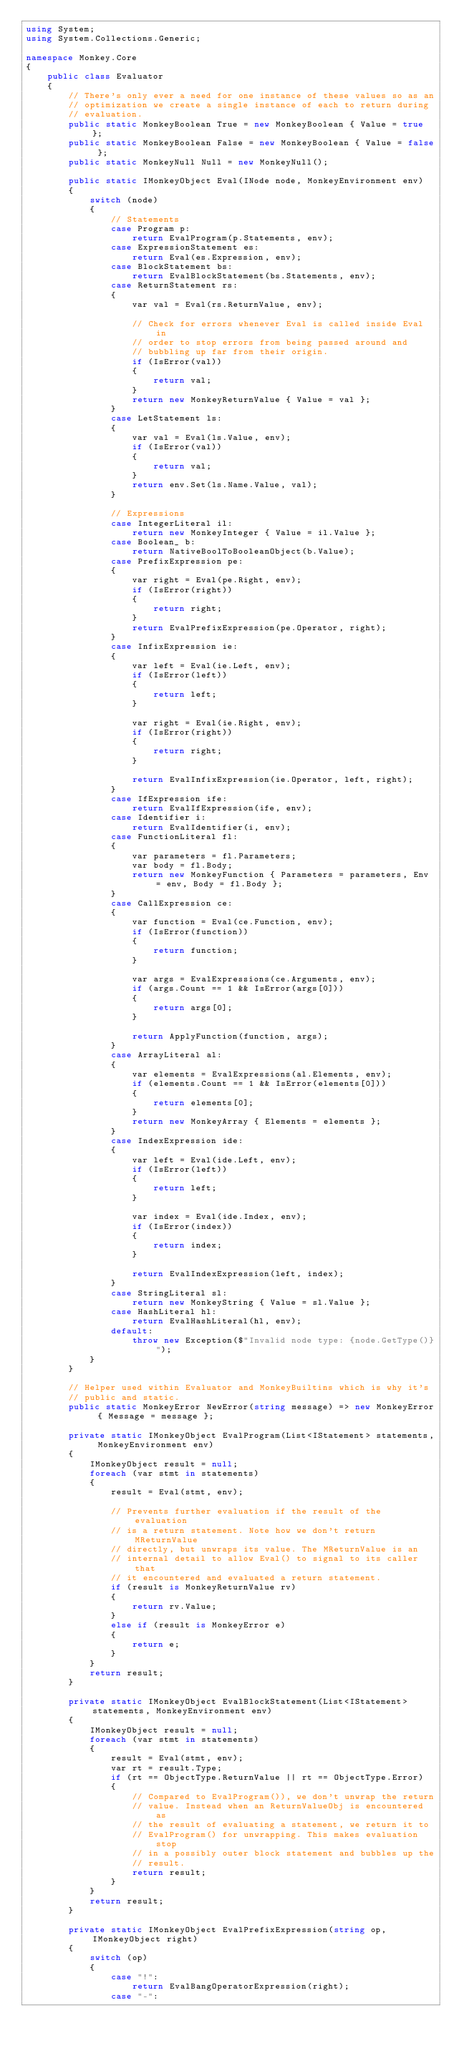Convert code to text. <code><loc_0><loc_0><loc_500><loc_500><_C#_>using System;
using System.Collections.Generic;

namespace Monkey.Core
{
    public class Evaluator
    {
        // There's only ever a need for one instance of these values so as an
        // optimization we create a single instance of each to return during
        // evaluation.
        public static MonkeyBoolean True = new MonkeyBoolean { Value = true };
        public static MonkeyBoolean False = new MonkeyBoolean { Value = false };
        public static MonkeyNull Null = new MonkeyNull();

        public static IMonkeyObject Eval(INode node, MonkeyEnvironment env)
        {
            switch (node)
            {
                // Statements
                case Program p:
                    return EvalProgram(p.Statements, env);
                case ExpressionStatement es:
                    return Eval(es.Expression, env);
                case BlockStatement bs:
                    return EvalBlockStatement(bs.Statements, env);
                case ReturnStatement rs:
                {
                    var val = Eval(rs.ReturnValue, env);

                    // Check for errors whenever Eval is called inside Eval in
                    // order to stop errors from being passed around and
                    // bubbling up far from their origin.
                    if (IsError(val))
                    {
                        return val;
                    }
                    return new MonkeyReturnValue { Value = val };
                }
                case LetStatement ls:
                {
                    var val = Eval(ls.Value, env);
                    if (IsError(val))
                    {
                        return val;
                    }
                    return env.Set(ls.Name.Value, val);
                }

                // Expressions
                case IntegerLiteral il:
                    return new MonkeyInteger { Value = il.Value };
                case Boolean_ b:
                    return NativeBoolToBooleanObject(b.Value);
                case PrefixExpression pe:
                {
                    var right = Eval(pe.Right, env);
                    if (IsError(right))
                    {
                        return right;
                    }
                    return EvalPrefixExpression(pe.Operator, right);
                }
                case InfixExpression ie:
                {
                    var left = Eval(ie.Left, env);
                    if (IsError(left))
                    {
                        return left;
                    }

                    var right = Eval(ie.Right, env);
                    if (IsError(right))
                    {
                        return right;
                    }

                    return EvalInfixExpression(ie.Operator, left, right);
                }
                case IfExpression ife:
                    return EvalIfExpression(ife, env);
                case Identifier i:
                    return EvalIdentifier(i, env);
                case FunctionLiteral fl:
                {
                    var parameters = fl.Parameters;   
                    var body = fl.Body;
                    return new MonkeyFunction { Parameters = parameters, Env = env, Body = fl.Body };
                }
                case CallExpression ce:
                {
                    var function = Eval(ce.Function, env);
                    if (IsError(function))
                    {
                        return function;
                    }
                    
                    var args = EvalExpressions(ce.Arguments, env);
                    if (args.Count == 1 && IsError(args[0]))
                    {
                        return args[0];
                    }

                    return ApplyFunction(function, args);
                }         
                case ArrayLiteral al:
                {
                    var elements = EvalExpressions(al.Elements, env);
                    if (elements.Count == 1 && IsError(elements[0]))
                    {
                        return elements[0];
                    }
                    return new MonkeyArray { Elements = elements };
                }       
                case IndexExpression ide:
                {
                    var left = Eval(ide.Left, env);
                    if (IsError(left))
                    {
                        return left;
                    }

                    var index = Eval(ide.Index, env);
                    if (IsError(index))
                    {
                        return index;
                    }

                    return EvalIndexExpression(left, index);
                }
                case StringLiteral sl:
                    return new MonkeyString { Value = sl.Value };
                case HashLiteral hl:
                    return EvalHashLiteral(hl, env);
                default:
                    throw new Exception($"Invalid node type: {node.GetType()}");                
            }
        }

        // Helper used within Evaluator and MonkeyBuiltins which is why it's
        // public and static.
        public static MonkeyError NewError(string message) => new MonkeyError { Message = message };

        private static IMonkeyObject EvalProgram(List<IStatement> statements, MonkeyEnvironment env)
        {
            IMonkeyObject result = null;
            foreach (var stmt in statements)
            {
                result = Eval(stmt, env);

                // Prevents further evaluation if the result of the evaluation
                // is a return statement. Note how we don't return MReturnValue
                // directly, but unwraps its value. The MReturnValue is an
                // internal detail to allow Eval() to signal to its caller that
                // it encountered and evaluated a return statement.
                if (result is MonkeyReturnValue rv)
                {
                    return rv.Value;
                }
                else if (result is MonkeyError e)
                {
                    return e;
                }
            }
            return result;
        }

        private static IMonkeyObject EvalBlockStatement(List<IStatement> statements, MonkeyEnvironment env)
        {
            IMonkeyObject result = null;
            foreach (var stmt in statements)
            {
                result = Eval(stmt, env);
                var rt = result.Type;
                if (rt == ObjectType.ReturnValue || rt == ObjectType.Error)
                {
                    // Compared to EvalProgram()), we don't unwrap the return
                    // value. Instead when an ReturnValueObj is encountered as
                    // the result of evaluating a statement, we return it to
                    // EvalProgram() for unwrapping. This makes evaluation stop
                    // in a possibly outer block statement and bubbles up the
                    // result.
                    return result;
                }
            }
            return result;
        }

        private static IMonkeyObject EvalPrefixExpression(string op, IMonkeyObject right)
        {
            switch (op)
            {
                case "!": 
                    return EvalBangOperatorExpression(right);
                case "-":</code> 